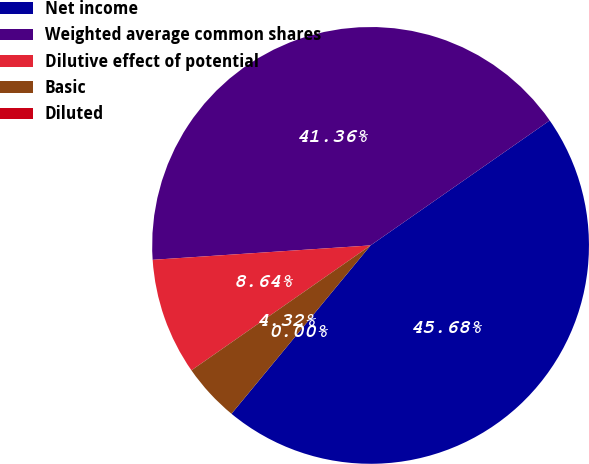<chart> <loc_0><loc_0><loc_500><loc_500><pie_chart><fcel>Net income<fcel>Weighted average common shares<fcel>Dilutive effect of potential<fcel>Basic<fcel>Diluted<nl><fcel>45.68%<fcel>41.36%<fcel>8.64%<fcel>4.32%<fcel>0.0%<nl></chart> 